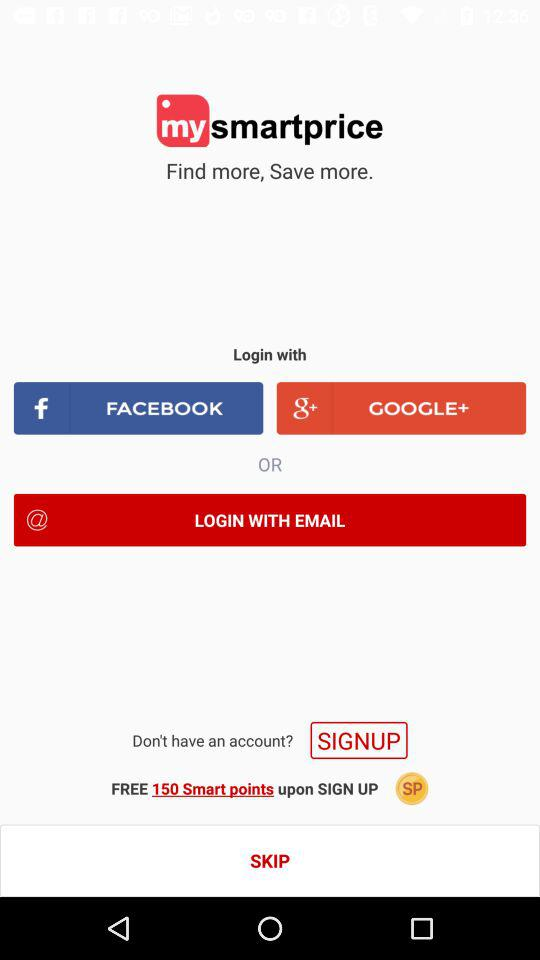How many free smart points do you get when you sign up?
Answer the question using a single word or phrase. 150 